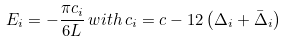Convert formula to latex. <formula><loc_0><loc_0><loc_500><loc_500>E _ { i } = - \frac { \pi c _ { i } } { 6 L } \, w i t h \, c _ { i } = c - 1 2 \left ( \Delta _ { i } + \bar { \Delta } _ { i } \right )</formula> 